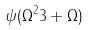<formula> <loc_0><loc_0><loc_500><loc_500>\psi ( \Omega ^ { 2 } 3 + \Omega )</formula> 